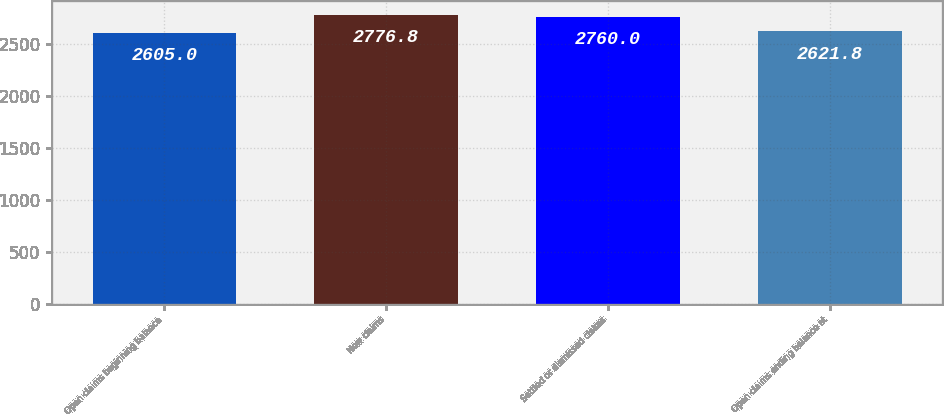Convert chart. <chart><loc_0><loc_0><loc_500><loc_500><bar_chart><fcel>Open claims beginning balance<fcel>New claims<fcel>Settled or dismissed claims<fcel>Open claims ending balance at<nl><fcel>2605<fcel>2776.8<fcel>2760<fcel>2621.8<nl></chart> 